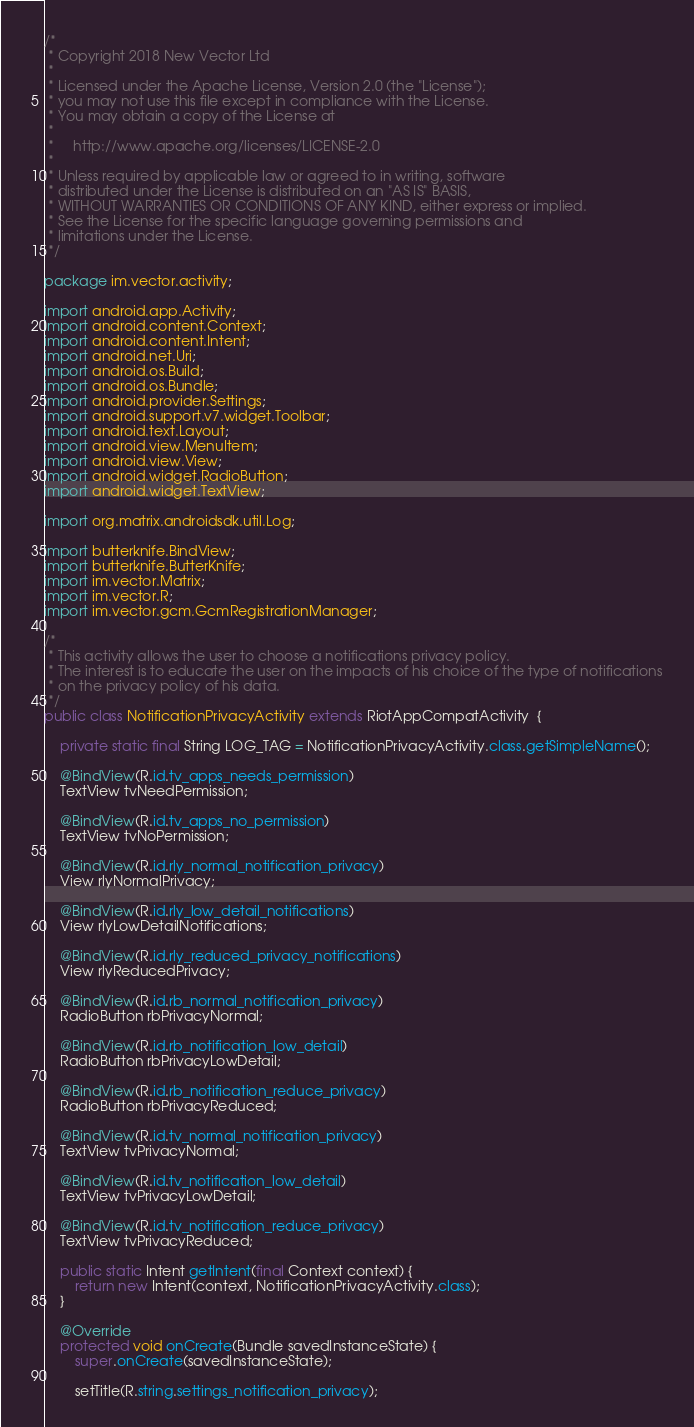<code> <loc_0><loc_0><loc_500><loc_500><_Java_>/*
 * Copyright 2018 New Vector Ltd
 *
 * Licensed under the Apache License, Version 2.0 (the "License");
 * you may not use this file except in compliance with the License.
 * You may obtain a copy of the License at
 *
 *     http://www.apache.org/licenses/LICENSE-2.0
 *
 * Unless required by applicable law or agreed to in writing, software
 * distributed under the License is distributed on an "AS IS" BASIS,
 * WITHOUT WARRANTIES OR CONDITIONS OF ANY KIND, either express or implied.
 * See the License for the specific language governing permissions and
 * limitations under the License.
 */

package im.vector.activity;

import android.app.Activity;
import android.content.Context;
import android.content.Intent;
import android.net.Uri;
import android.os.Build;
import android.os.Bundle;
import android.provider.Settings;
import android.support.v7.widget.Toolbar;
import android.text.Layout;
import android.view.MenuItem;
import android.view.View;
import android.widget.RadioButton;
import android.widget.TextView;

import org.matrix.androidsdk.util.Log;

import butterknife.BindView;
import butterknife.ButterKnife;
import im.vector.Matrix;
import im.vector.R;
import im.vector.gcm.GcmRegistrationManager;

/*
 * This activity allows the user to choose a notifications privacy policy.
 * The interest is to educate the user on the impacts of his choice of the type of notifications
 * on the privacy policy of his data.
 */
public class NotificationPrivacyActivity extends RiotAppCompatActivity  {

    private static final String LOG_TAG = NotificationPrivacyActivity.class.getSimpleName();

    @BindView(R.id.tv_apps_needs_permission)
    TextView tvNeedPermission;

    @BindView(R.id.tv_apps_no_permission)
    TextView tvNoPermission;

    @BindView(R.id.rly_normal_notification_privacy)
    View rlyNormalPrivacy;

    @BindView(R.id.rly_low_detail_notifications)
    View rlyLowDetailNotifications;

    @BindView(R.id.rly_reduced_privacy_notifications)
    View rlyReducedPrivacy;

    @BindView(R.id.rb_normal_notification_privacy)
    RadioButton rbPrivacyNormal;

    @BindView(R.id.rb_notification_low_detail)
    RadioButton rbPrivacyLowDetail;

    @BindView(R.id.rb_notification_reduce_privacy)
    RadioButton rbPrivacyReduced;

    @BindView(R.id.tv_normal_notification_privacy)
    TextView tvPrivacyNormal;

    @BindView(R.id.tv_notification_low_detail)
    TextView tvPrivacyLowDetail;

    @BindView(R.id.tv_notification_reduce_privacy)
    TextView tvPrivacyReduced;

    public static Intent getIntent(final Context context) {
        return new Intent(context, NotificationPrivacyActivity.class);
    }

    @Override
    protected void onCreate(Bundle savedInstanceState) {
        super.onCreate(savedInstanceState);

        setTitle(R.string.settings_notification_privacy);</code> 